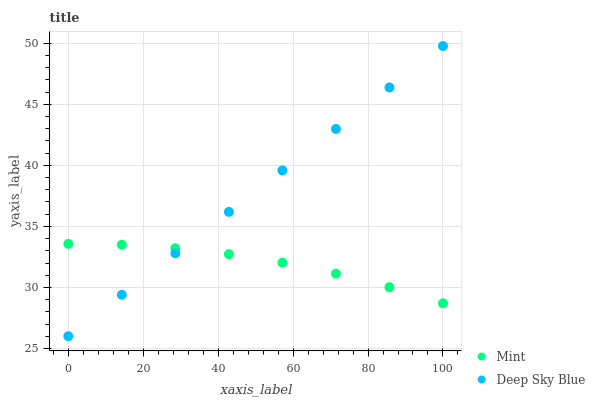Does Mint have the minimum area under the curve?
Answer yes or no. Yes. Does Deep Sky Blue have the maximum area under the curve?
Answer yes or no. Yes. Does Deep Sky Blue have the minimum area under the curve?
Answer yes or no. No. Is Deep Sky Blue the smoothest?
Answer yes or no. Yes. Is Mint the roughest?
Answer yes or no. Yes. Is Deep Sky Blue the roughest?
Answer yes or no. No. Does Deep Sky Blue have the lowest value?
Answer yes or no. Yes. Does Deep Sky Blue have the highest value?
Answer yes or no. Yes. Does Mint intersect Deep Sky Blue?
Answer yes or no. Yes. Is Mint less than Deep Sky Blue?
Answer yes or no. No. Is Mint greater than Deep Sky Blue?
Answer yes or no. No. 